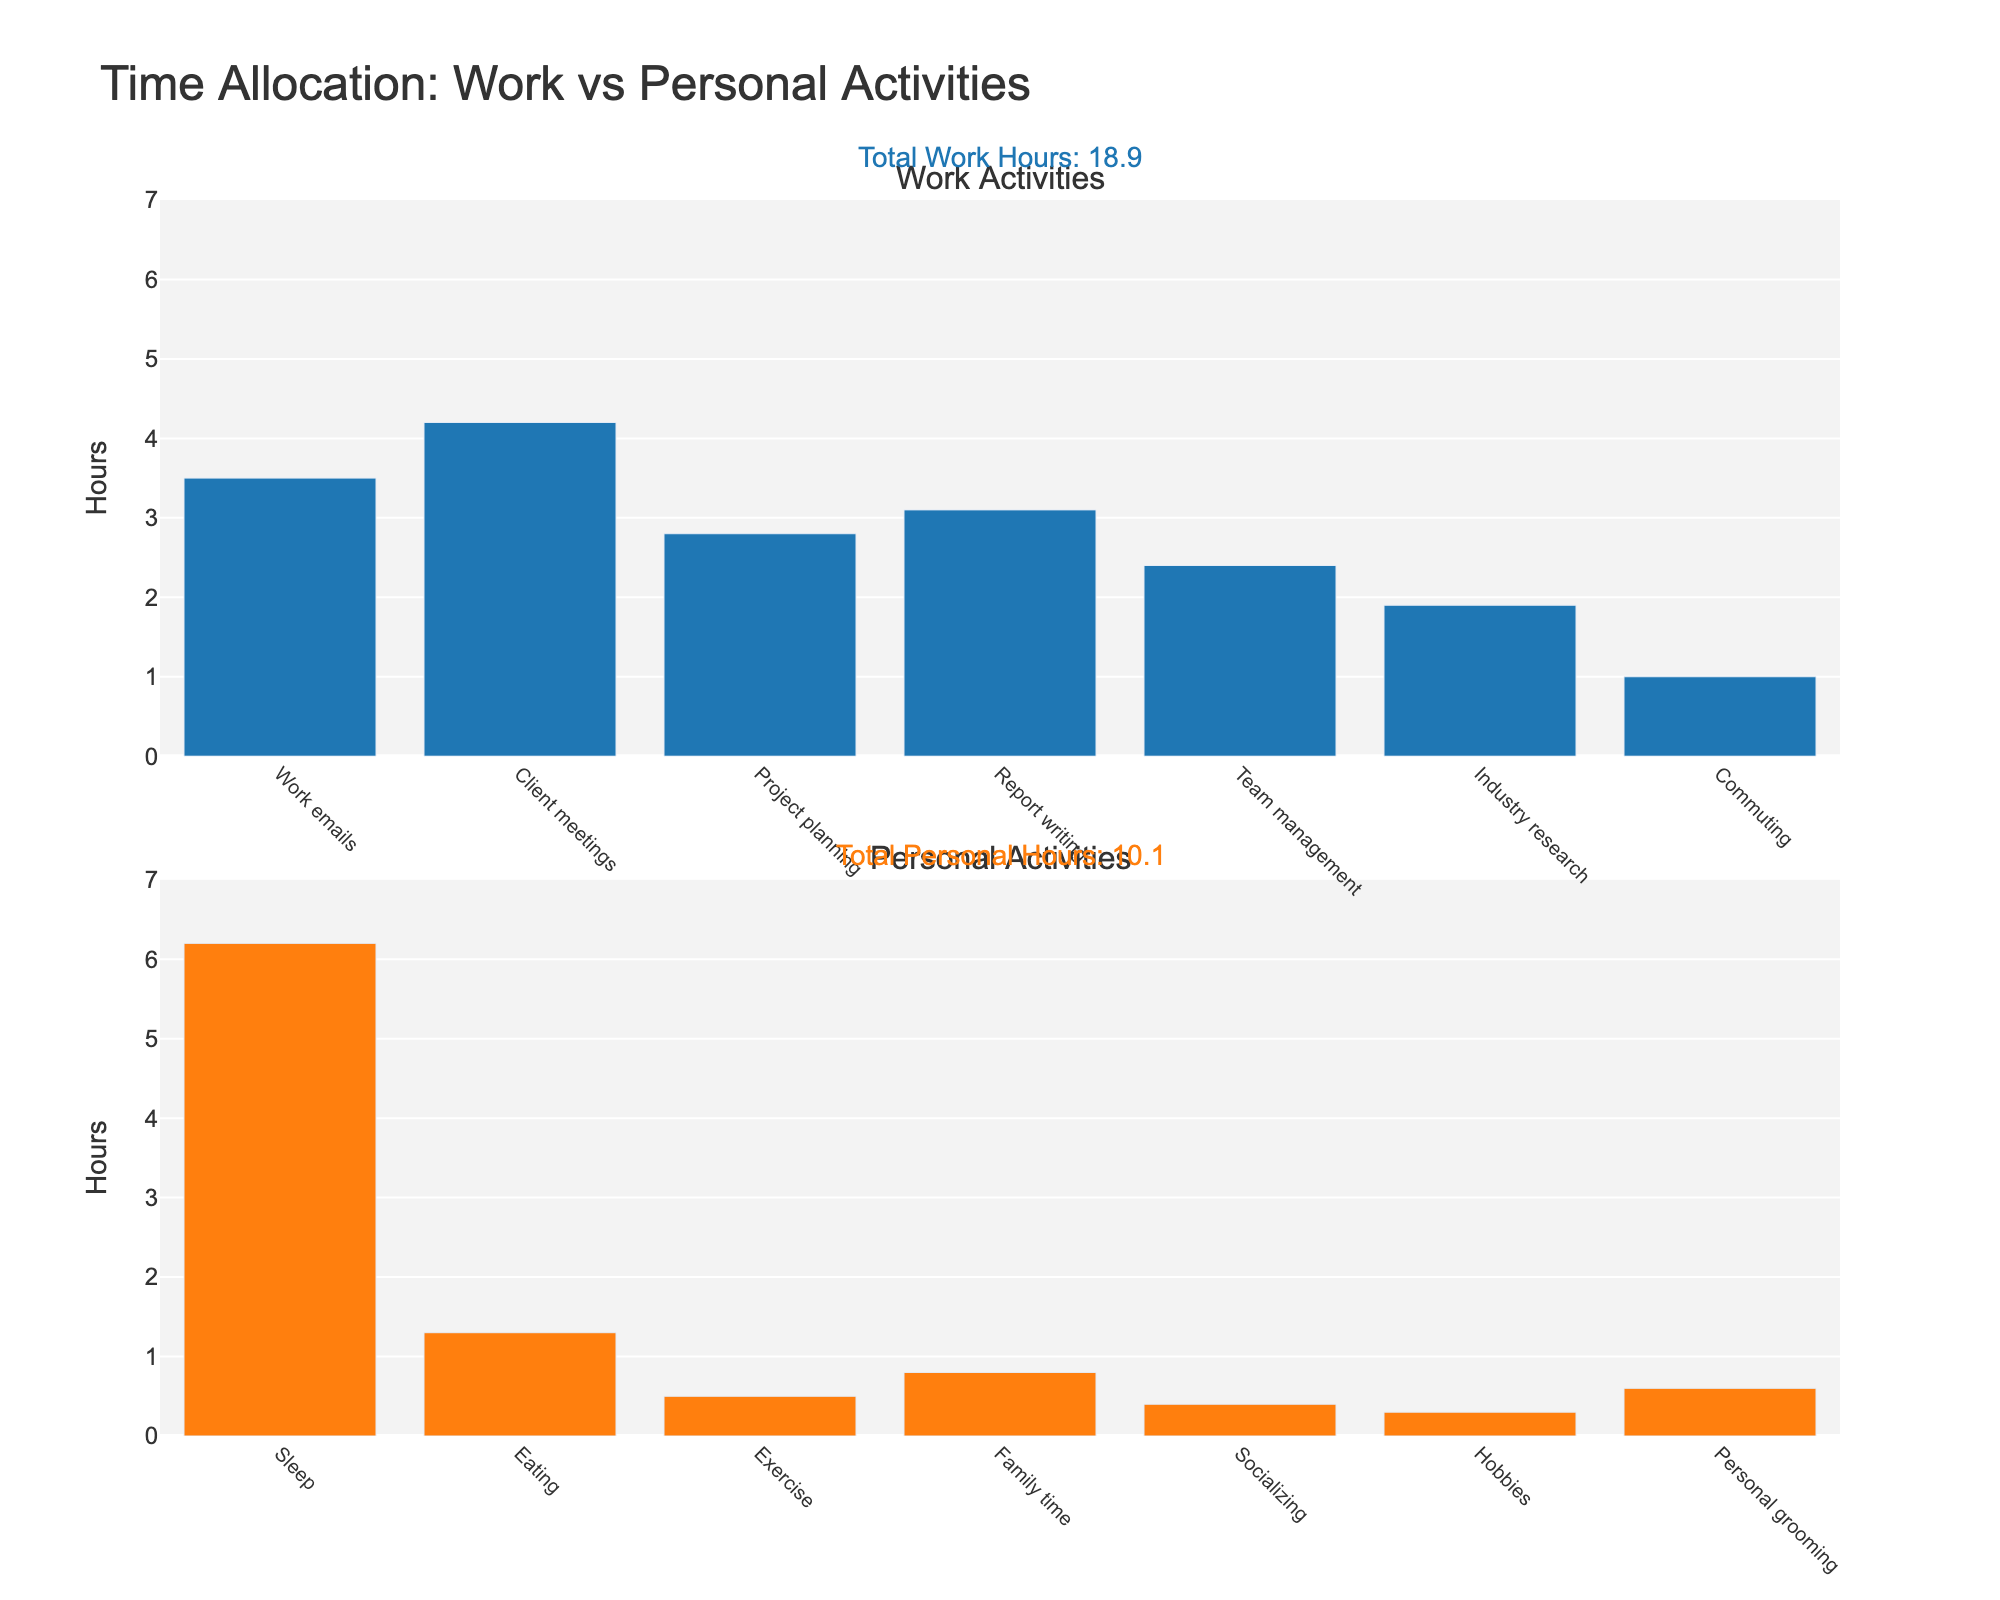How many total hours are dedicated to work activities? Look at the first histogram labeled "Work Activities" and sum all the hours for each activity. The total hours are given in the annotation "Total Work Hours".
Answer: 20.2 Which activity consumes the most time in personal activities? Review the second histogram labeled "Personal Activities" and identify the bar with the highest value. Sleep has the tallest bar at 6.2 hours.
Answer: Sleep What is the difference in total hours spent on work activities versus personal activities? According to the annotations, total work hours are 20.2, and total personal hours are 10.1. The difference is 20.2 - 10.1.
Answer: 10.1 How much time is spent each day on eating? Refer to the second histogram labeled "Personal Activities" and find the bar for Eating, which shows 1.3 hours.
Answer: 1.3 Compared to family time, how much more time is spent on team management? In the first histogram, team management is 2.4 hours; family time in the second histogram is 0.8 hours. 2.4 - 0.8.
Answer: 1.6 What percentage of time is spent on client meetings relative to the total work hours? Client meetings take 4.2 hours out of a total of 20.2 work hours. Calculate the percentage (4.2/20.2)*100.
Answer: 20.8% Which work-related activity takes less than 2 hours? In the first histogram, industry research takes 1.9 hours, which is less than 2 hours.
Answer: Industry research Is more time spent on exercise or personal grooming? Compare the bars for Exercise (0.5 hours) and Personal grooming (0.6 hours) in the second histogram. Personal grooming is greater.
Answer: Personal grooming What is the sum of hours allocated to personal activities like exercise, family time, and hobbies? Sum the hours for Exercise (0.5), Family time (0.8), and Hobbies (0.3), which are all found in the second histogram. 0.5 + 0.8 + 0.3.
Answer: 1.6 